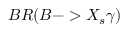Convert formula to latex. <formula><loc_0><loc_0><loc_500><loc_500>B R ( B - > X _ { s } \gamma )</formula> 